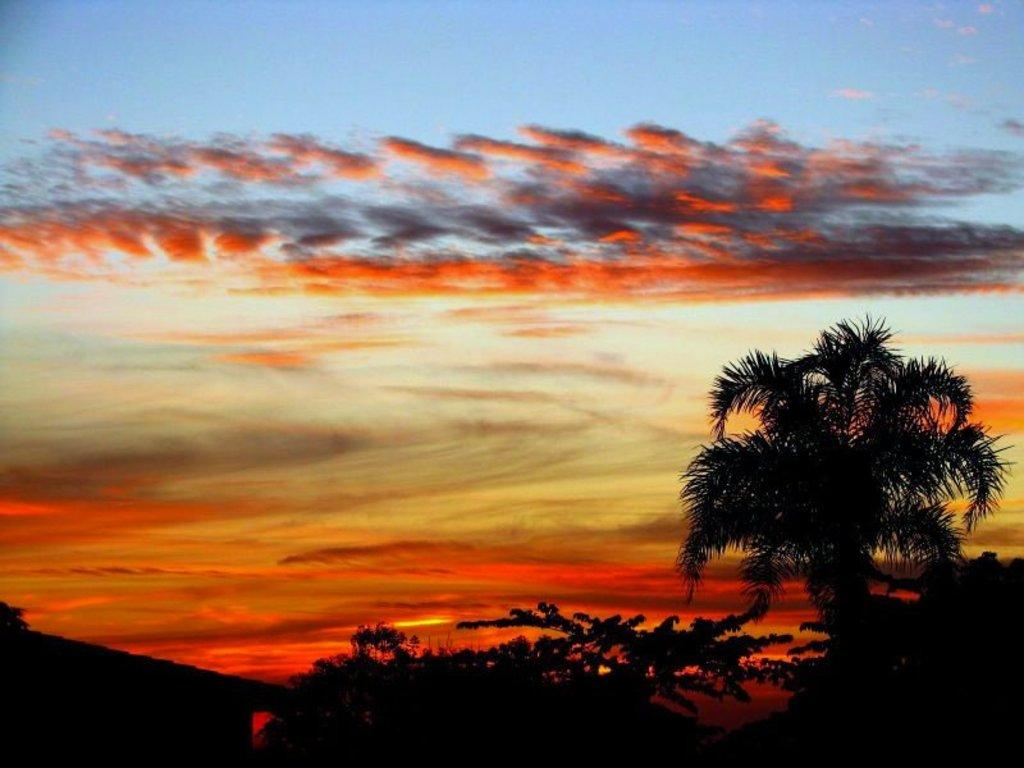What type of vegetation can be seen in the image? There are trees in the image. What is visible in the background of the image? The sky is visible in the image. What can be observed in the sky? Clouds are present in the sky. What type of creature can be seen playing during recess in the image? There is no creature or recess present in the image; it only features trees and the sky. 